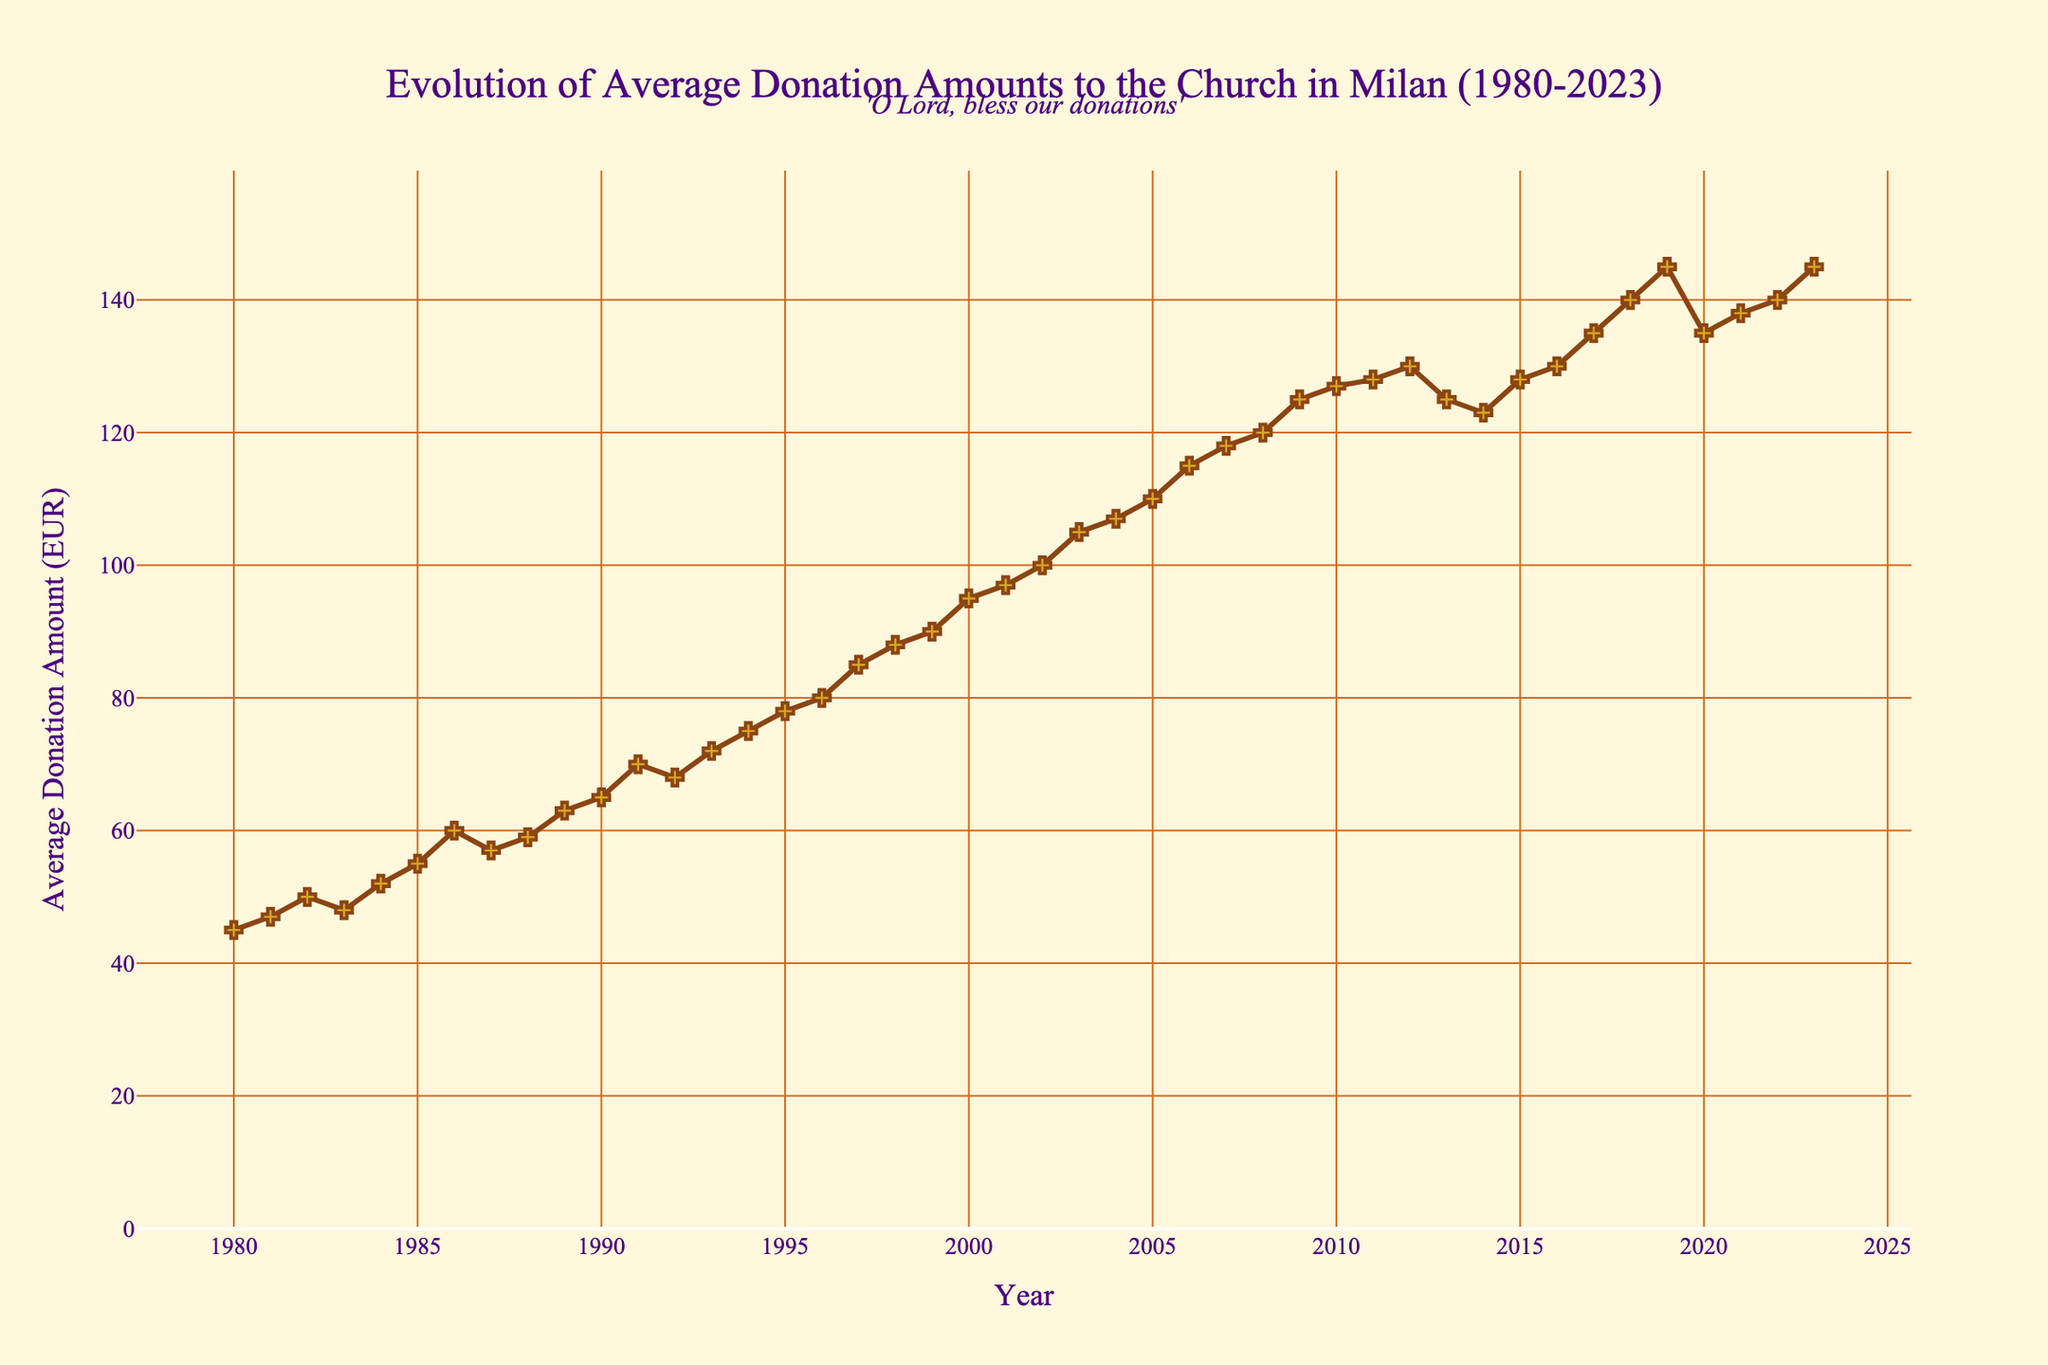How many data points are there in the figure? Count the number of years on the x-axis from 1980 to 2023. Each year corresponds to one data point, so count all the ticks.
Answer: 44 What is the title of the figure? Look at the top of the figure where the title is usually located.
Answer: Evolution of Average Donation Amounts to the Church in Milan (1980-2023) What is the average donation amount in the year 2000? Locate the year 2000 on the x-axis and find the corresponding y-axis value.
Answer: 95 EUR In which year did the average donation amount reach 100 EUR for the first time? Trace the plot line from left to right and identify the year where the y-axis value first hits 100 EUR.
Answer: 2002 Did the average donation amount increase or decrease between the years 2019 and 2020? Compare the y-axis values for the years 2019 and 2020 by observing the height of the points.
Answer: Decrease What was the highest average donation amount and when did it occur? Find the highest point on the y-axis and note the corresponding year.
Answer: 145 EUR, 2019 and 2023 Between which consecutive years did the average donation amount increase the most? Calculate the differences between consecutive years and identify the largest difference.
Answer: 1996-1997 What is the general trend of the average donations from 1980 to 2023? Observe the overall direction of the plot line from start to end.
Answer: Increasing 